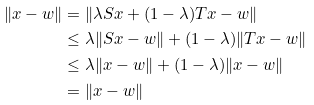Convert formula to latex. <formula><loc_0><loc_0><loc_500><loc_500>\| x - w \| & = \| \lambda S x + ( 1 - \lambda ) T x - w \| \\ & \leq \lambda \| S x - w \| + ( 1 - \lambda ) \| T x - w \| \\ & \leq \lambda \| x - w \| + ( 1 - \lambda ) \| x - w \| \\ & = \| x - w \|</formula> 